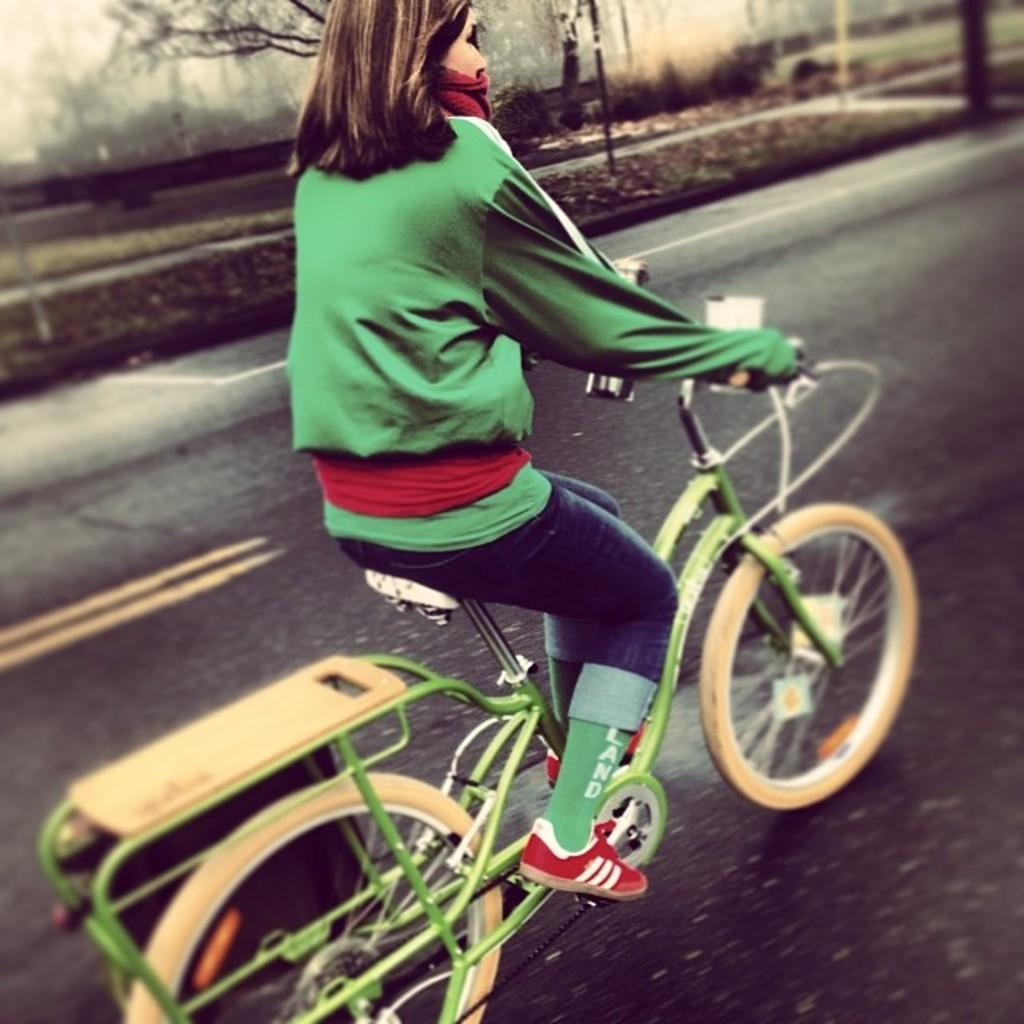What is the person in the image doing? There is a person riding a bicycle in the image. Where is the person riding the bicycle? The person is on a road. What can be seen in the background of the image? There are trees visible in the image. What type of plate is being used to ride the bicycle in the image? There is no plate present in the image; the person is riding a bicycle. 